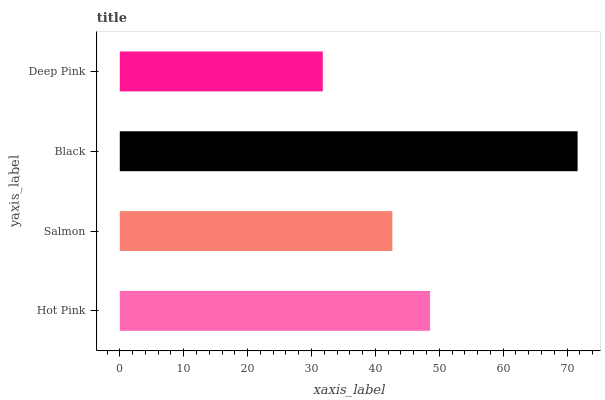Is Deep Pink the minimum?
Answer yes or no. Yes. Is Black the maximum?
Answer yes or no. Yes. Is Salmon the minimum?
Answer yes or no. No. Is Salmon the maximum?
Answer yes or no. No. Is Hot Pink greater than Salmon?
Answer yes or no. Yes. Is Salmon less than Hot Pink?
Answer yes or no. Yes. Is Salmon greater than Hot Pink?
Answer yes or no. No. Is Hot Pink less than Salmon?
Answer yes or no. No. Is Hot Pink the high median?
Answer yes or no. Yes. Is Salmon the low median?
Answer yes or no. Yes. Is Black the high median?
Answer yes or no. No. Is Black the low median?
Answer yes or no. No. 